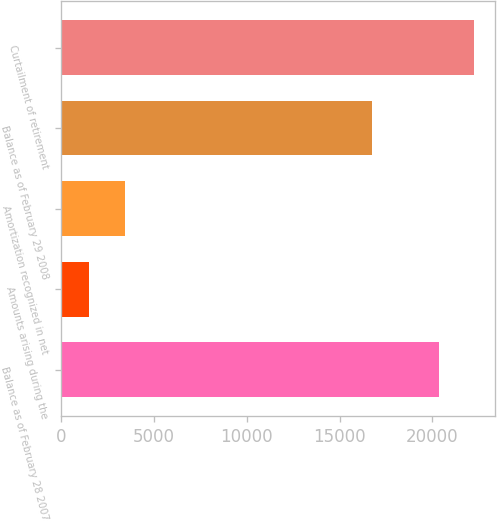Convert chart. <chart><loc_0><loc_0><loc_500><loc_500><bar_chart><fcel>Balance as of February 28 2007<fcel>Amounts arising during the<fcel>Amortization recognized in net<fcel>Balance as of February 29 2008<fcel>Curtailment of retirement<nl><fcel>20332<fcel>1515<fcel>3440.5<fcel>16728<fcel>22257.5<nl></chart> 